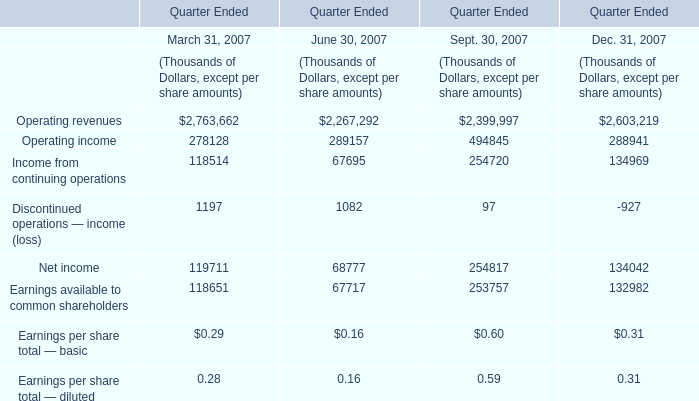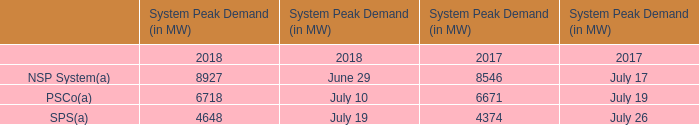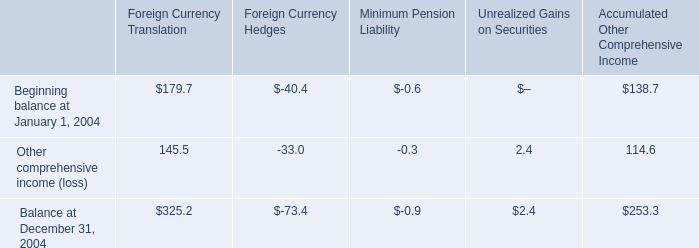What is the average value of Operating revenues in March 31, 2007 and NSP System(a) in 2018? (in thousand) 
Computations: ((2763662 + 8927) / 2)
Answer: 1386294.5. 